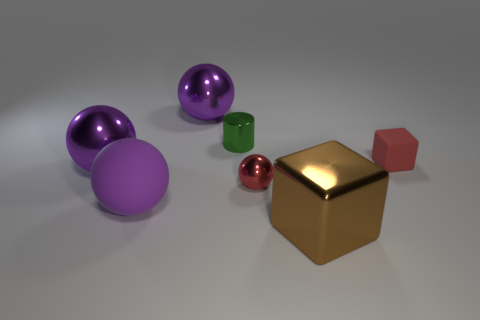Is there a green metal sphere that has the same size as the red ball?
Your response must be concise. No. What is the color of the tiny ball that is the same material as the green cylinder?
Provide a short and direct response. Red. There is a shiny object that is on the right side of the small shiny ball; what number of large rubber balls are behind it?
Your answer should be very brief. 1. What material is the tiny object that is both in front of the cylinder and left of the red matte block?
Give a very brief answer. Metal. Do the matte thing on the right side of the large matte thing and the tiny red shiny thing have the same shape?
Offer a very short reply. No. Are there fewer metallic cylinders than large spheres?
Keep it short and to the point. Yes. What number of small metallic objects are the same color as the rubber cube?
Make the answer very short. 1. What material is the tiny cube that is the same color as the small sphere?
Offer a terse response. Rubber. There is a big metal block; does it have the same color as the thing to the right of the brown metal thing?
Provide a short and direct response. No. Are there more red metallic things than small green metal balls?
Give a very brief answer. Yes. 